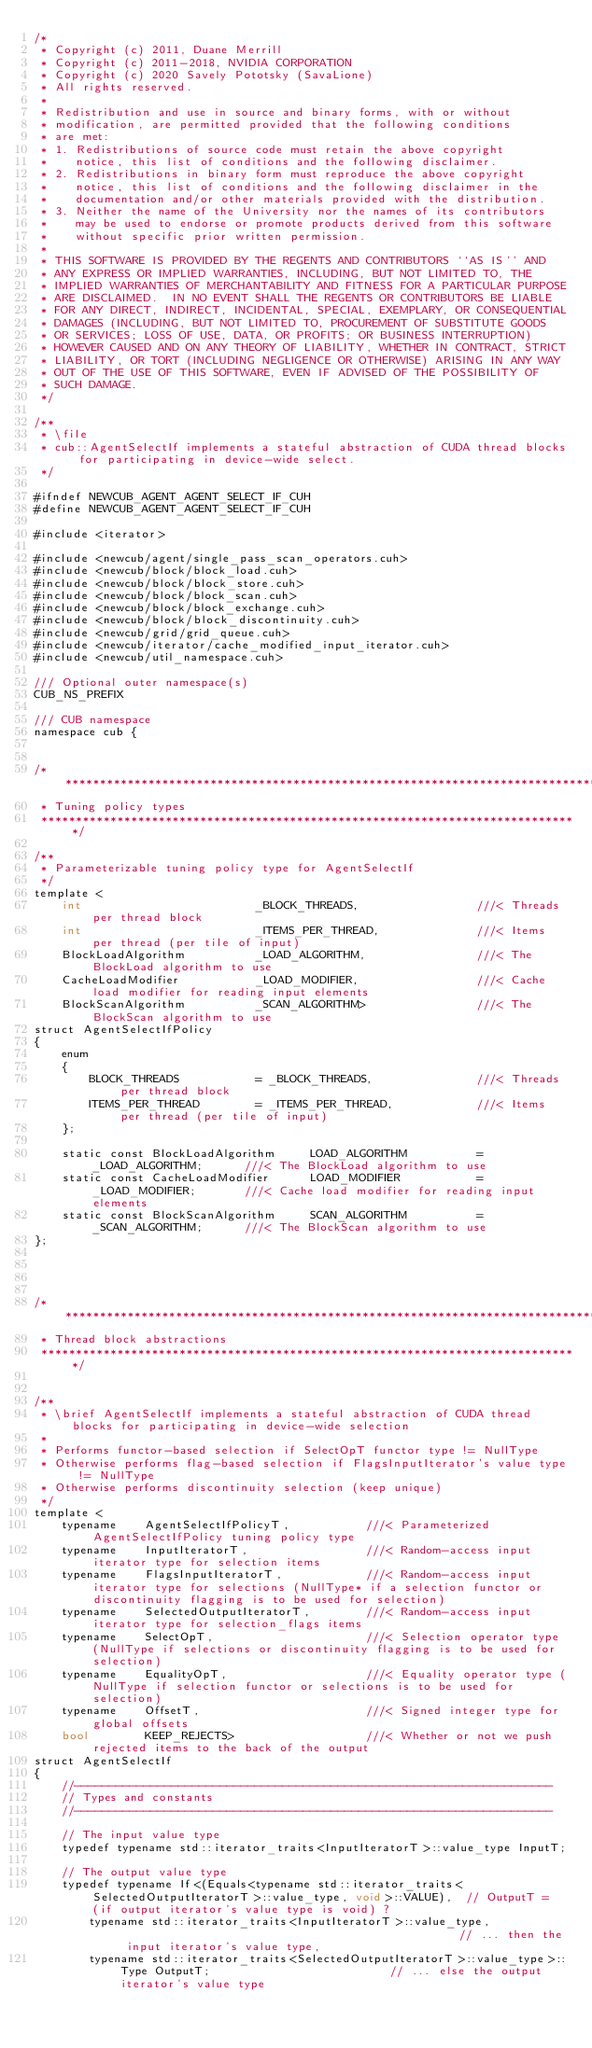<code> <loc_0><loc_0><loc_500><loc_500><_Cuda_>/*
 * Copyright (c) 2011, Duane Merrill
 * Copyright (c) 2011-2018, NVIDIA CORPORATION
 * Copyright (c) 2020 Savely Pototsky (SavaLione)
 * All rights reserved.
 *
 * Redistribution and use in source and binary forms, with or without
 * modification, are permitted provided that the following conditions
 * are met:
 * 1. Redistributions of source code must retain the above copyright
 *    notice, this list of conditions and the following disclaimer.
 * 2. Redistributions in binary form must reproduce the above copyright
 *    notice, this list of conditions and the following disclaimer in the
 *    documentation and/or other materials provided with the distribution.
 * 3. Neither the name of the University nor the names of its contributors
 *    may be used to endorse or promote products derived from this software
 *    without specific prior written permission.
 *
 * THIS SOFTWARE IS PROVIDED BY THE REGENTS AND CONTRIBUTORS ``AS IS'' AND
 * ANY EXPRESS OR IMPLIED WARRANTIES, INCLUDING, BUT NOT LIMITED TO, THE
 * IMPLIED WARRANTIES OF MERCHANTABILITY AND FITNESS FOR A PARTICULAR PURPOSE
 * ARE DISCLAIMED.  IN NO EVENT SHALL THE REGENTS OR CONTRIBUTORS BE LIABLE
 * FOR ANY DIRECT, INDIRECT, INCIDENTAL, SPECIAL, EXEMPLARY, OR CONSEQUENTIAL
 * DAMAGES (INCLUDING, BUT NOT LIMITED TO, PROCUREMENT OF SUBSTITUTE GOODS
 * OR SERVICES; LOSS OF USE, DATA, OR PROFITS; OR BUSINESS INTERRUPTION)
 * HOWEVER CAUSED AND ON ANY THEORY OF LIABILITY, WHETHER IN CONTRACT, STRICT
 * LIABILITY, OR TORT (INCLUDING NEGLIGENCE OR OTHERWISE) ARISING IN ANY WAY
 * OUT OF THE USE OF THIS SOFTWARE, EVEN IF ADVISED OF THE POSSIBILITY OF
 * SUCH DAMAGE.
 */

/**
 * \file
 * cub::AgentSelectIf implements a stateful abstraction of CUDA thread blocks for participating in device-wide select.
 */

#ifndef NEWCUB_AGENT_AGENT_SELECT_IF_CUH
#define NEWCUB_AGENT_AGENT_SELECT_IF_CUH

#include <iterator>

#include <newcub/agent/single_pass_scan_operators.cuh>
#include <newcub/block/block_load.cuh>
#include <newcub/block/block_store.cuh>
#include <newcub/block/block_scan.cuh>
#include <newcub/block/block_exchange.cuh>
#include <newcub/block/block_discontinuity.cuh>
#include <newcub/grid/grid_queue.cuh>
#include <newcub/iterator/cache_modified_input_iterator.cuh>
#include <newcub/util_namespace.cuh>

/// Optional outer namespace(s)
CUB_NS_PREFIX

/// CUB namespace
namespace cub {


/******************************************************************************
 * Tuning policy types
 ******************************************************************************/

/**
 * Parameterizable tuning policy type for AgentSelectIf
 */
template <
    int                         _BLOCK_THREADS,                 ///< Threads per thread block
    int                         _ITEMS_PER_THREAD,              ///< Items per thread (per tile of input)
    BlockLoadAlgorithm          _LOAD_ALGORITHM,                ///< The BlockLoad algorithm to use
    CacheLoadModifier           _LOAD_MODIFIER,                 ///< Cache load modifier for reading input elements
    BlockScanAlgorithm          _SCAN_ALGORITHM>                ///< The BlockScan algorithm to use
struct AgentSelectIfPolicy
{
    enum
    {
        BLOCK_THREADS           = _BLOCK_THREADS,               ///< Threads per thread block
        ITEMS_PER_THREAD        = _ITEMS_PER_THREAD,            ///< Items per thread (per tile of input)
    };

    static const BlockLoadAlgorithm     LOAD_ALGORITHM          = _LOAD_ALGORITHM;      ///< The BlockLoad algorithm to use
    static const CacheLoadModifier      LOAD_MODIFIER           = _LOAD_MODIFIER;       ///< Cache load modifier for reading input elements
    static const BlockScanAlgorithm     SCAN_ALGORITHM          = _SCAN_ALGORITHM;      ///< The BlockScan algorithm to use
};




/******************************************************************************
 * Thread block abstractions
 ******************************************************************************/


/**
 * \brief AgentSelectIf implements a stateful abstraction of CUDA thread blocks for participating in device-wide selection
 *
 * Performs functor-based selection if SelectOpT functor type != NullType
 * Otherwise performs flag-based selection if FlagsInputIterator's value type != NullType
 * Otherwise performs discontinuity selection (keep unique)
 */
template <
    typename    AgentSelectIfPolicyT,           ///< Parameterized AgentSelectIfPolicy tuning policy type
    typename    InputIteratorT,                 ///< Random-access input iterator type for selection items
    typename    FlagsInputIteratorT,            ///< Random-access input iterator type for selections (NullType* if a selection functor or discontinuity flagging is to be used for selection)
    typename    SelectedOutputIteratorT,        ///< Random-access input iterator type for selection_flags items
    typename    SelectOpT,                      ///< Selection operator type (NullType if selections or discontinuity flagging is to be used for selection)
    typename    EqualityOpT,                    ///< Equality operator type (NullType if selection functor or selections is to be used for selection)
    typename    OffsetT,                        ///< Signed integer type for global offsets
    bool        KEEP_REJECTS>                   ///< Whether or not we push rejected items to the back of the output
struct AgentSelectIf
{
    //---------------------------------------------------------------------
    // Types and constants
    //---------------------------------------------------------------------

    // The input value type
    typedef typename std::iterator_traits<InputIteratorT>::value_type InputT;

    // The output value type
    typedef typename If<(Equals<typename std::iterator_traits<SelectedOutputIteratorT>::value_type, void>::VALUE),  // OutputT =  (if output iterator's value type is void) ?
        typename std::iterator_traits<InputIteratorT>::value_type,                                                  // ... then the input iterator's value type,
        typename std::iterator_traits<SelectedOutputIteratorT>::value_type>::Type OutputT;                          // ... else the output iterator's value type
</code> 